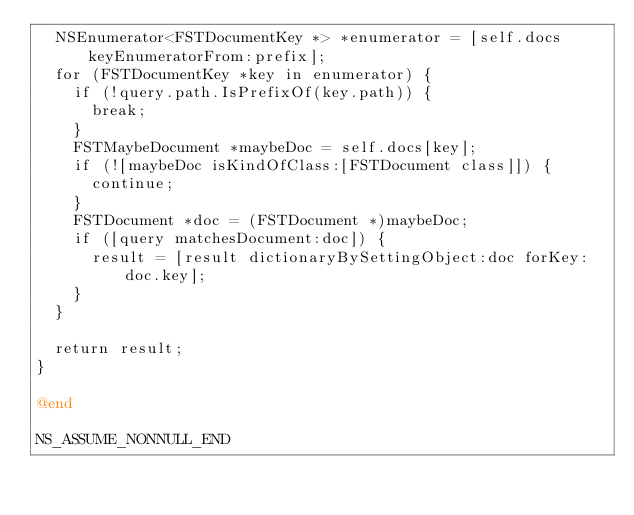Convert code to text. <code><loc_0><loc_0><loc_500><loc_500><_ObjectiveC_>  NSEnumerator<FSTDocumentKey *> *enumerator = [self.docs keyEnumeratorFrom:prefix];
  for (FSTDocumentKey *key in enumerator) {
    if (!query.path.IsPrefixOf(key.path)) {
      break;
    }
    FSTMaybeDocument *maybeDoc = self.docs[key];
    if (![maybeDoc isKindOfClass:[FSTDocument class]]) {
      continue;
    }
    FSTDocument *doc = (FSTDocument *)maybeDoc;
    if ([query matchesDocument:doc]) {
      result = [result dictionaryBySettingObject:doc forKey:doc.key];
    }
  }

  return result;
}

@end

NS_ASSUME_NONNULL_END
</code> 